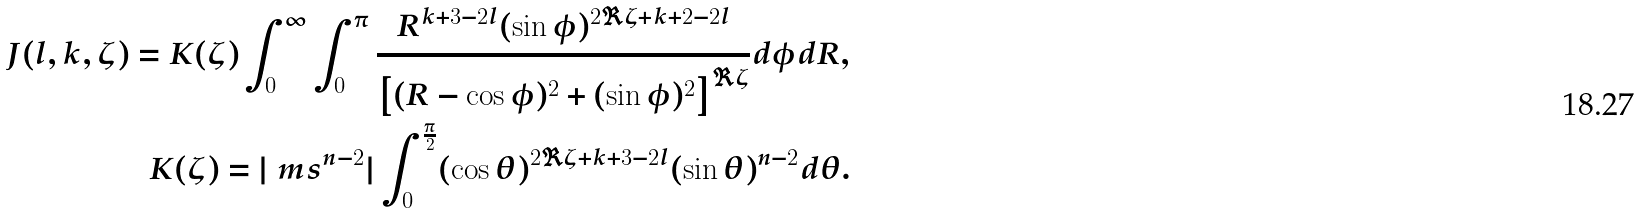Convert formula to latex. <formula><loc_0><loc_0><loc_500><loc_500>J ( l , k , \zeta ) = K ( \zeta ) \int _ { 0 } ^ { \infty } \int _ { 0 } ^ { \pi } \frac { R ^ { k + 3 - 2 l } ( \sin \phi ) ^ { 2 \Re \zeta + k + 2 - 2 l } } { \left [ ( R - \cos \phi ) ^ { 2 } + ( \sin \phi ) ^ { 2 } \right ] ^ { \Re \zeta } } d \phi d R , \\ K ( \zeta ) = | \ m s ^ { n - 2 } | \int _ { 0 } ^ { \frac { \pi } { 2 } } ( \cos \theta ) ^ { 2 \Re \zeta + k + 3 - 2 l } ( \sin \theta ) ^ { n - 2 } d \theta .</formula> 